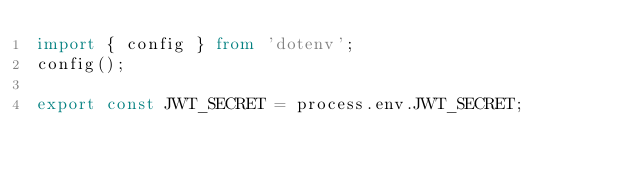<code> <loc_0><loc_0><loc_500><loc_500><_TypeScript_>import { config } from 'dotenv';
config();

export const JWT_SECRET = process.env.JWT_SECRET;
</code> 